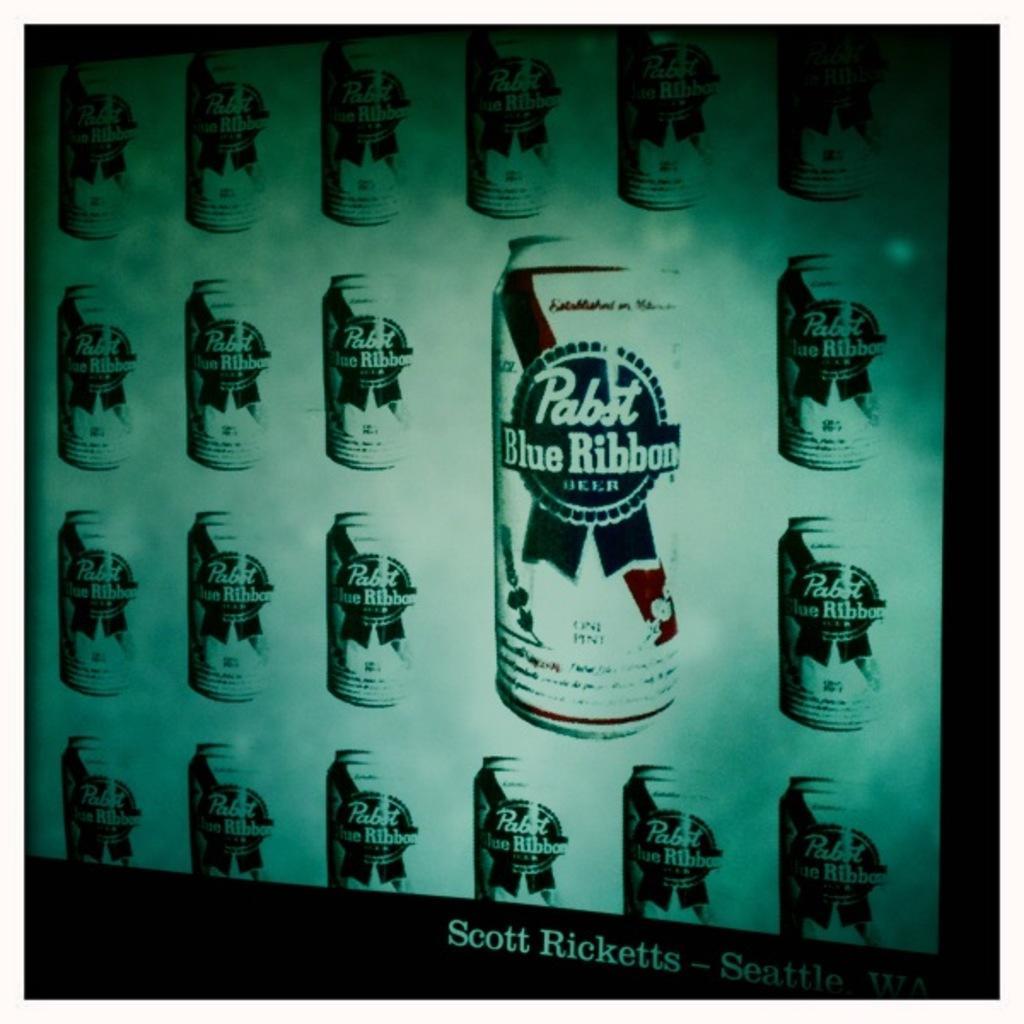How would you summarize this image in a sentence or two? In this picture, we see the television screen which is displaying the coke bottles or it might be a banner. In the background, it is white in color. At the bottom, it is black in color. This picture might be clicked in the dark. 